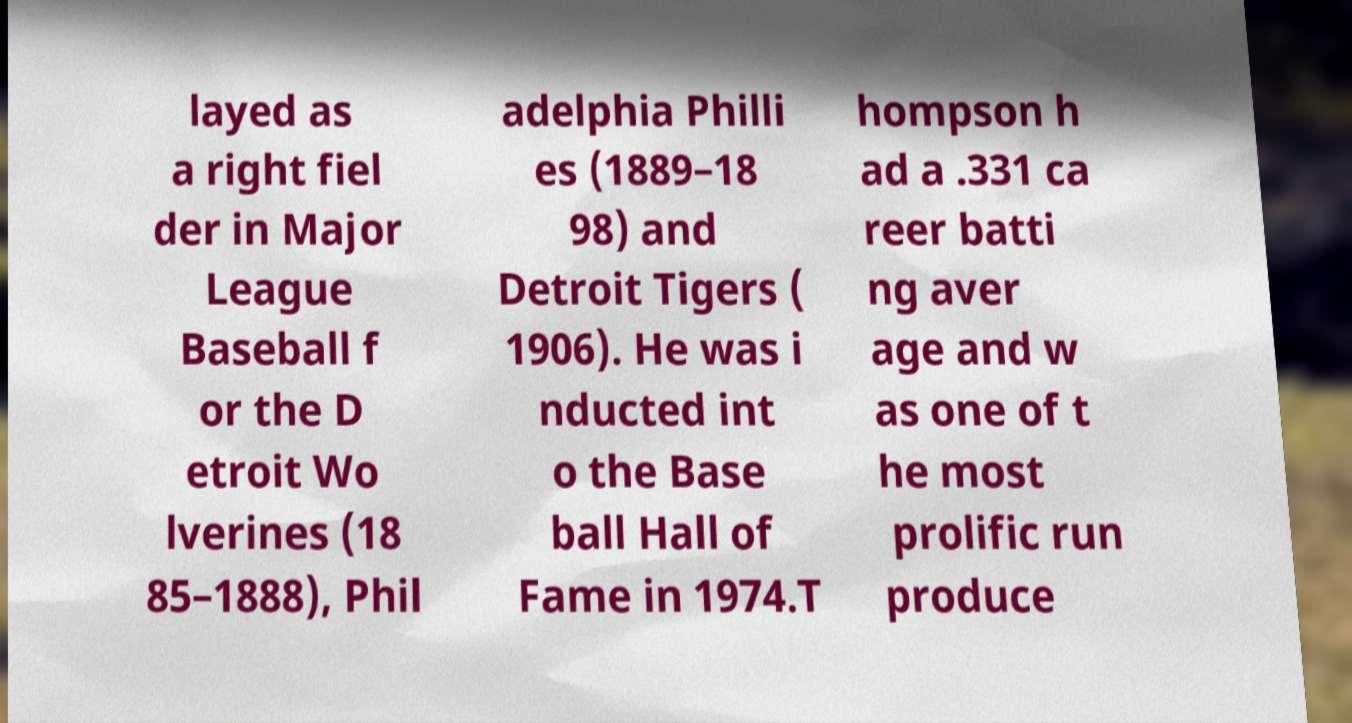Could you extract and type out the text from this image? layed as a right fiel der in Major League Baseball f or the D etroit Wo lverines (18 85–1888), Phil adelphia Philli es (1889–18 98) and Detroit Tigers ( 1906). He was i nducted int o the Base ball Hall of Fame in 1974.T hompson h ad a .331 ca reer batti ng aver age and w as one of t he most prolific run produce 